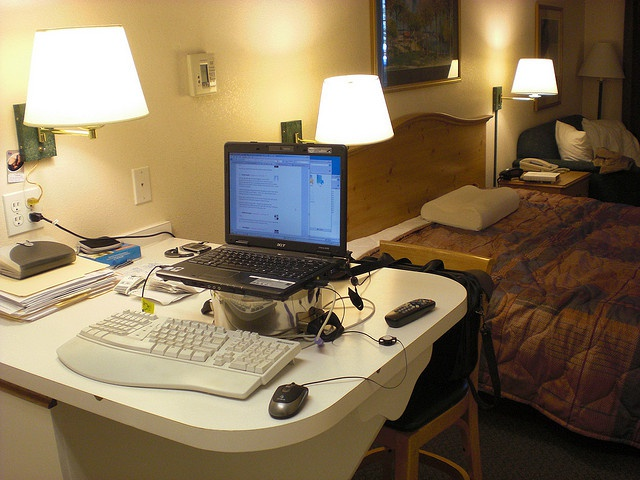Describe the objects in this image and their specific colors. I can see bed in beige, black, maroon, and olive tones, laptop in beige, black, darkgray, and gray tones, keyboard in beige and tan tones, chair in beige, black, maroon, and olive tones, and couch in beige, black, maroon, and tan tones in this image. 